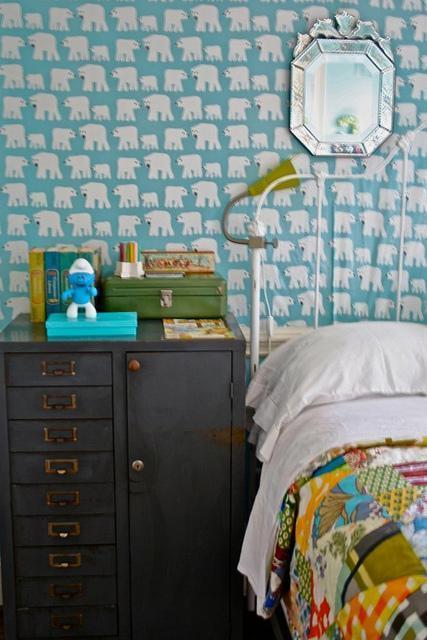How many knobs?
Give a very brief answer. 2. 